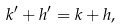<formula> <loc_0><loc_0><loc_500><loc_500>k ^ { \prime } + h ^ { \prime } = k + h ,</formula> 